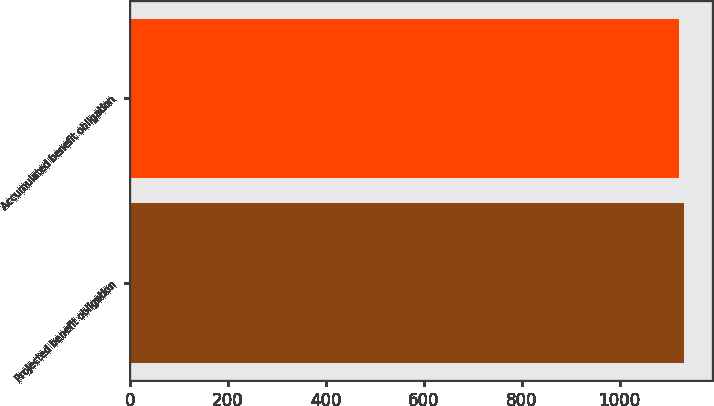<chart> <loc_0><loc_0><loc_500><loc_500><bar_chart><fcel>Projected benefit obligation<fcel>Accumulated benefit obligation<nl><fcel>1131<fcel>1122<nl></chart> 